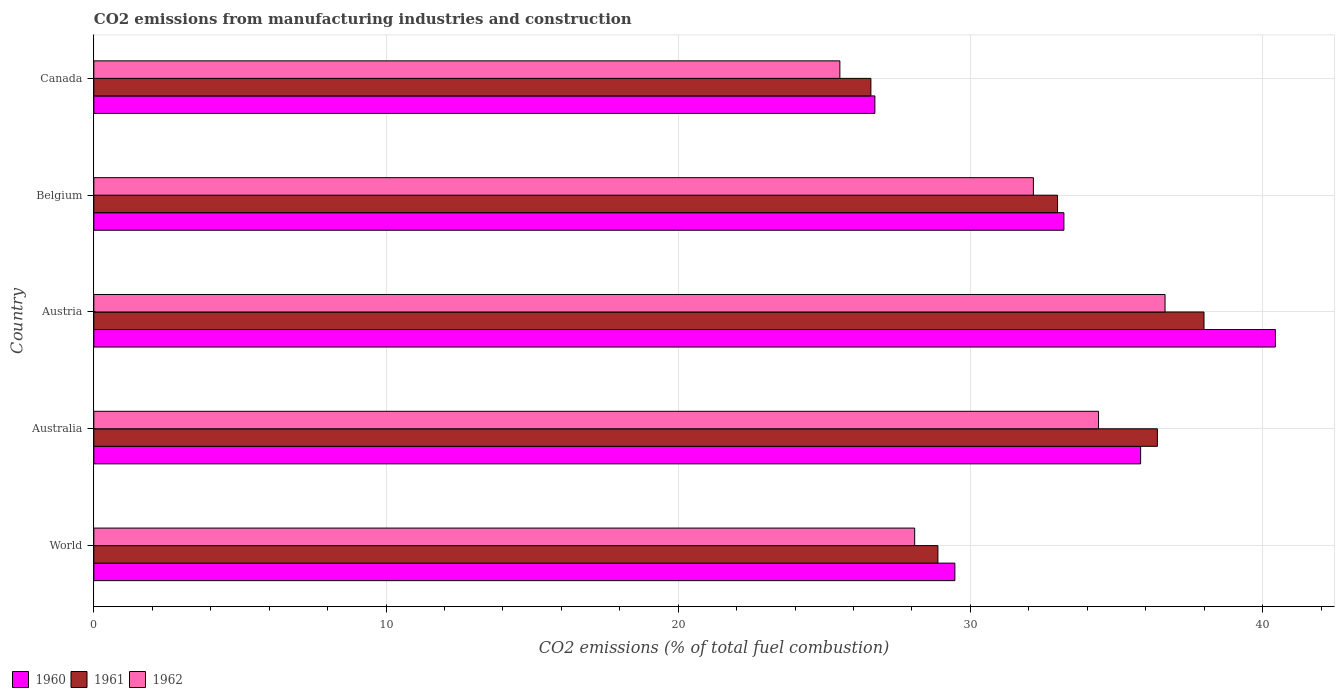How many bars are there on the 4th tick from the top?
Offer a very short reply. 3. How many bars are there on the 1st tick from the bottom?
Provide a short and direct response. 3. In how many cases, is the number of bars for a given country not equal to the number of legend labels?
Offer a terse response. 0. What is the amount of CO2 emitted in 1961 in Austria?
Offer a very short reply. 37.99. Across all countries, what is the maximum amount of CO2 emitted in 1961?
Your response must be concise. 37.99. Across all countries, what is the minimum amount of CO2 emitted in 1960?
Your response must be concise. 26.73. In which country was the amount of CO2 emitted in 1960 maximum?
Make the answer very short. Austria. What is the total amount of CO2 emitted in 1961 in the graph?
Your answer should be very brief. 162.86. What is the difference between the amount of CO2 emitted in 1960 in Australia and that in Canada?
Make the answer very short. 9.1. What is the difference between the amount of CO2 emitted in 1961 in Belgium and the amount of CO2 emitted in 1960 in Australia?
Your response must be concise. -2.84. What is the average amount of CO2 emitted in 1962 per country?
Ensure brevity in your answer.  31.37. What is the difference between the amount of CO2 emitted in 1960 and amount of CO2 emitted in 1962 in World?
Offer a very short reply. 1.38. What is the ratio of the amount of CO2 emitted in 1960 in Austria to that in Canada?
Make the answer very short. 1.51. Is the amount of CO2 emitted in 1960 in Australia less than that in Canada?
Ensure brevity in your answer.  No. What is the difference between the highest and the second highest amount of CO2 emitted in 1960?
Offer a very short reply. 4.61. What is the difference between the highest and the lowest amount of CO2 emitted in 1961?
Offer a terse response. 11.4. In how many countries, is the amount of CO2 emitted in 1960 greater than the average amount of CO2 emitted in 1960 taken over all countries?
Your response must be concise. 3. What does the 1st bar from the top in Austria represents?
Provide a succinct answer. 1962. What does the 2nd bar from the bottom in Canada represents?
Provide a succinct answer. 1961. Is it the case that in every country, the sum of the amount of CO2 emitted in 1961 and amount of CO2 emitted in 1960 is greater than the amount of CO2 emitted in 1962?
Keep it short and to the point. Yes. Are all the bars in the graph horizontal?
Provide a succinct answer. Yes. How many countries are there in the graph?
Your answer should be very brief. 5. Does the graph contain any zero values?
Offer a very short reply. No. Does the graph contain grids?
Ensure brevity in your answer.  Yes. How are the legend labels stacked?
Your response must be concise. Horizontal. What is the title of the graph?
Give a very brief answer. CO2 emissions from manufacturing industries and construction. What is the label or title of the X-axis?
Keep it short and to the point. CO2 emissions (% of total fuel combustion). What is the label or title of the Y-axis?
Offer a very short reply. Country. What is the CO2 emissions (% of total fuel combustion) of 1960 in World?
Ensure brevity in your answer.  29.47. What is the CO2 emissions (% of total fuel combustion) of 1961 in World?
Your response must be concise. 28.89. What is the CO2 emissions (% of total fuel combustion) in 1962 in World?
Ensure brevity in your answer.  28.09. What is the CO2 emissions (% of total fuel combustion) in 1960 in Australia?
Offer a terse response. 35.83. What is the CO2 emissions (% of total fuel combustion) of 1961 in Australia?
Make the answer very short. 36.4. What is the CO2 emissions (% of total fuel combustion) in 1962 in Australia?
Make the answer very short. 34.39. What is the CO2 emissions (% of total fuel combustion) in 1960 in Austria?
Give a very brief answer. 40.44. What is the CO2 emissions (% of total fuel combustion) of 1961 in Austria?
Provide a succinct answer. 37.99. What is the CO2 emissions (% of total fuel combustion) in 1962 in Austria?
Your answer should be compact. 36.66. What is the CO2 emissions (% of total fuel combustion) in 1960 in Belgium?
Your answer should be compact. 33.2. What is the CO2 emissions (% of total fuel combustion) of 1961 in Belgium?
Your answer should be very brief. 32.98. What is the CO2 emissions (% of total fuel combustion) in 1962 in Belgium?
Ensure brevity in your answer.  32.16. What is the CO2 emissions (% of total fuel combustion) of 1960 in Canada?
Provide a succinct answer. 26.73. What is the CO2 emissions (% of total fuel combustion) in 1961 in Canada?
Your answer should be compact. 26.59. What is the CO2 emissions (% of total fuel combustion) of 1962 in Canada?
Give a very brief answer. 25.53. Across all countries, what is the maximum CO2 emissions (% of total fuel combustion) in 1960?
Make the answer very short. 40.44. Across all countries, what is the maximum CO2 emissions (% of total fuel combustion) of 1961?
Offer a terse response. 37.99. Across all countries, what is the maximum CO2 emissions (% of total fuel combustion) in 1962?
Offer a very short reply. 36.66. Across all countries, what is the minimum CO2 emissions (% of total fuel combustion) in 1960?
Make the answer very short. 26.73. Across all countries, what is the minimum CO2 emissions (% of total fuel combustion) in 1961?
Offer a very short reply. 26.59. Across all countries, what is the minimum CO2 emissions (% of total fuel combustion) of 1962?
Ensure brevity in your answer.  25.53. What is the total CO2 emissions (% of total fuel combustion) of 1960 in the graph?
Provide a succinct answer. 165.66. What is the total CO2 emissions (% of total fuel combustion) of 1961 in the graph?
Offer a terse response. 162.86. What is the total CO2 emissions (% of total fuel combustion) in 1962 in the graph?
Offer a terse response. 156.83. What is the difference between the CO2 emissions (% of total fuel combustion) of 1960 in World and that in Australia?
Offer a terse response. -6.36. What is the difference between the CO2 emissions (% of total fuel combustion) in 1961 in World and that in Australia?
Offer a terse response. -7.51. What is the difference between the CO2 emissions (% of total fuel combustion) in 1962 in World and that in Australia?
Your response must be concise. -6.29. What is the difference between the CO2 emissions (% of total fuel combustion) in 1960 in World and that in Austria?
Your answer should be compact. -10.97. What is the difference between the CO2 emissions (% of total fuel combustion) of 1961 in World and that in Austria?
Your response must be concise. -9.11. What is the difference between the CO2 emissions (% of total fuel combustion) of 1962 in World and that in Austria?
Your answer should be very brief. -8.57. What is the difference between the CO2 emissions (% of total fuel combustion) in 1960 in World and that in Belgium?
Ensure brevity in your answer.  -3.73. What is the difference between the CO2 emissions (% of total fuel combustion) in 1961 in World and that in Belgium?
Provide a succinct answer. -4.09. What is the difference between the CO2 emissions (% of total fuel combustion) of 1962 in World and that in Belgium?
Offer a very short reply. -4.06. What is the difference between the CO2 emissions (% of total fuel combustion) of 1960 in World and that in Canada?
Make the answer very short. 2.74. What is the difference between the CO2 emissions (% of total fuel combustion) in 1961 in World and that in Canada?
Your answer should be very brief. 2.29. What is the difference between the CO2 emissions (% of total fuel combustion) of 1962 in World and that in Canada?
Make the answer very short. 2.56. What is the difference between the CO2 emissions (% of total fuel combustion) of 1960 in Australia and that in Austria?
Keep it short and to the point. -4.61. What is the difference between the CO2 emissions (% of total fuel combustion) of 1961 in Australia and that in Austria?
Provide a succinct answer. -1.6. What is the difference between the CO2 emissions (% of total fuel combustion) of 1962 in Australia and that in Austria?
Make the answer very short. -2.28. What is the difference between the CO2 emissions (% of total fuel combustion) in 1960 in Australia and that in Belgium?
Your response must be concise. 2.63. What is the difference between the CO2 emissions (% of total fuel combustion) in 1961 in Australia and that in Belgium?
Provide a short and direct response. 3.42. What is the difference between the CO2 emissions (% of total fuel combustion) in 1962 in Australia and that in Belgium?
Give a very brief answer. 2.23. What is the difference between the CO2 emissions (% of total fuel combustion) in 1960 in Australia and that in Canada?
Your response must be concise. 9.1. What is the difference between the CO2 emissions (% of total fuel combustion) of 1961 in Australia and that in Canada?
Give a very brief answer. 9.81. What is the difference between the CO2 emissions (% of total fuel combustion) in 1962 in Australia and that in Canada?
Offer a very short reply. 8.85. What is the difference between the CO2 emissions (% of total fuel combustion) in 1960 in Austria and that in Belgium?
Offer a very short reply. 7.24. What is the difference between the CO2 emissions (% of total fuel combustion) in 1961 in Austria and that in Belgium?
Give a very brief answer. 5.01. What is the difference between the CO2 emissions (% of total fuel combustion) of 1962 in Austria and that in Belgium?
Your response must be concise. 4.51. What is the difference between the CO2 emissions (% of total fuel combustion) of 1960 in Austria and that in Canada?
Your answer should be compact. 13.71. What is the difference between the CO2 emissions (% of total fuel combustion) in 1961 in Austria and that in Canada?
Offer a terse response. 11.4. What is the difference between the CO2 emissions (% of total fuel combustion) of 1962 in Austria and that in Canada?
Give a very brief answer. 11.13. What is the difference between the CO2 emissions (% of total fuel combustion) of 1960 in Belgium and that in Canada?
Make the answer very short. 6.47. What is the difference between the CO2 emissions (% of total fuel combustion) of 1961 in Belgium and that in Canada?
Provide a succinct answer. 6.39. What is the difference between the CO2 emissions (% of total fuel combustion) of 1962 in Belgium and that in Canada?
Ensure brevity in your answer.  6.62. What is the difference between the CO2 emissions (% of total fuel combustion) in 1960 in World and the CO2 emissions (% of total fuel combustion) in 1961 in Australia?
Provide a short and direct response. -6.93. What is the difference between the CO2 emissions (% of total fuel combustion) in 1960 in World and the CO2 emissions (% of total fuel combustion) in 1962 in Australia?
Your answer should be very brief. -4.92. What is the difference between the CO2 emissions (% of total fuel combustion) of 1961 in World and the CO2 emissions (% of total fuel combustion) of 1962 in Australia?
Offer a very short reply. -5.5. What is the difference between the CO2 emissions (% of total fuel combustion) of 1960 in World and the CO2 emissions (% of total fuel combustion) of 1961 in Austria?
Ensure brevity in your answer.  -8.53. What is the difference between the CO2 emissions (% of total fuel combustion) in 1960 in World and the CO2 emissions (% of total fuel combustion) in 1962 in Austria?
Your answer should be very brief. -7.19. What is the difference between the CO2 emissions (% of total fuel combustion) of 1961 in World and the CO2 emissions (% of total fuel combustion) of 1962 in Austria?
Give a very brief answer. -7.77. What is the difference between the CO2 emissions (% of total fuel combustion) in 1960 in World and the CO2 emissions (% of total fuel combustion) in 1961 in Belgium?
Your response must be concise. -3.51. What is the difference between the CO2 emissions (% of total fuel combustion) in 1960 in World and the CO2 emissions (% of total fuel combustion) in 1962 in Belgium?
Provide a succinct answer. -2.69. What is the difference between the CO2 emissions (% of total fuel combustion) in 1961 in World and the CO2 emissions (% of total fuel combustion) in 1962 in Belgium?
Give a very brief answer. -3.27. What is the difference between the CO2 emissions (% of total fuel combustion) of 1960 in World and the CO2 emissions (% of total fuel combustion) of 1961 in Canada?
Offer a very short reply. 2.87. What is the difference between the CO2 emissions (% of total fuel combustion) in 1960 in World and the CO2 emissions (% of total fuel combustion) in 1962 in Canada?
Your answer should be compact. 3.94. What is the difference between the CO2 emissions (% of total fuel combustion) in 1961 in World and the CO2 emissions (% of total fuel combustion) in 1962 in Canada?
Keep it short and to the point. 3.35. What is the difference between the CO2 emissions (% of total fuel combustion) in 1960 in Australia and the CO2 emissions (% of total fuel combustion) in 1961 in Austria?
Your answer should be compact. -2.17. What is the difference between the CO2 emissions (% of total fuel combustion) of 1960 in Australia and the CO2 emissions (% of total fuel combustion) of 1962 in Austria?
Offer a terse response. -0.84. What is the difference between the CO2 emissions (% of total fuel combustion) in 1961 in Australia and the CO2 emissions (% of total fuel combustion) in 1962 in Austria?
Make the answer very short. -0.26. What is the difference between the CO2 emissions (% of total fuel combustion) in 1960 in Australia and the CO2 emissions (% of total fuel combustion) in 1961 in Belgium?
Your answer should be very brief. 2.84. What is the difference between the CO2 emissions (% of total fuel combustion) in 1960 in Australia and the CO2 emissions (% of total fuel combustion) in 1962 in Belgium?
Make the answer very short. 3.67. What is the difference between the CO2 emissions (% of total fuel combustion) of 1961 in Australia and the CO2 emissions (% of total fuel combustion) of 1962 in Belgium?
Give a very brief answer. 4.24. What is the difference between the CO2 emissions (% of total fuel combustion) in 1960 in Australia and the CO2 emissions (% of total fuel combustion) in 1961 in Canada?
Offer a very short reply. 9.23. What is the difference between the CO2 emissions (% of total fuel combustion) of 1960 in Australia and the CO2 emissions (% of total fuel combustion) of 1962 in Canada?
Give a very brief answer. 10.29. What is the difference between the CO2 emissions (% of total fuel combustion) in 1961 in Australia and the CO2 emissions (% of total fuel combustion) in 1962 in Canada?
Your answer should be very brief. 10.87. What is the difference between the CO2 emissions (% of total fuel combustion) of 1960 in Austria and the CO2 emissions (% of total fuel combustion) of 1961 in Belgium?
Offer a very short reply. 7.46. What is the difference between the CO2 emissions (% of total fuel combustion) of 1960 in Austria and the CO2 emissions (% of total fuel combustion) of 1962 in Belgium?
Offer a terse response. 8.28. What is the difference between the CO2 emissions (% of total fuel combustion) in 1961 in Austria and the CO2 emissions (% of total fuel combustion) in 1962 in Belgium?
Your response must be concise. 5.84. What is the difference between the CO2 emissions (% of total fuel combustion) in 1960 in Austria and the CO2 emissions (% of total fuel combustion) in 1961 in Canada?
Offer a terse response. 13.84. What is the difference between the CO2 emissions (% of total fuel combustion) of 1960 in Austria and the CO2 emissions (% of total fuel combustion) of 1962 in Canada?
Provide a succinct answer. 14.91. What is the difference between the CO2 emissions (% of total fuel combustion) in 1961 in Austria and the CO2 emissions (% of total fuel combustion) in 1962 in Canada?
Offer a very short reply. 12.46. What is the difference between the CO2 emissions (% of total fuel combustion) of 1960 in Belgium and the CO2 emissions (% of total fuel combustion) of 1961 in Canada?
Offer a very short reply. 6.61. What is the difference between the CO2 emissions (% of total fuel combustion) of 1960 in Belgium and the CO2 emissions (% of total fuel combustion) of 1962 in Canada?
Provide a short and direct response. 7.67. What is the difference between the CO2 emissions (% of total fuel combustion) of 1961 in Belgium and the CO2 emissions (% of total fuel combustion) of 1962 in Canada?
Your answer should be compact. 7.45. What is the average CO2 emissions (% of total fuel combustion) in 1960 per country?
Your answer should be compact. 33.13. What is the average CO2 emissions (% of total fuel combustion) of 1961 per country?
Make the answer very short. 32.57. What is the average CO2 emissions (% of total fuel combustion) of 1962 per country?
Your answer should be very brief. 31.37. What is the difference between the CO2 emissions (% of total fuel combustion) in 1960 and CO2 emissions (% of total fuel combustion) in 1961 in World?
Give a very brief answer. 0.58. What is the difference between the CO2 emissions (% of total fuel combustion) in 1960 and CO2 emissions (% of total fuel combustion) in 1962 in World?
Give a very brief answer. 1.38. What is the difference between the CO2 emissions (% of total fuel combustion) in 1961 and CO2 emissions (% of total fuel combustion) in 1962 in World?
Provide a succinct answer. 0.79. What is the difference between the CO2 emissions (% of total fuel combustion) in 1960 and CO2 emissions (% of total fuel combustion) in 1961 in Australia?
Keep it short and to the point. -0.57. What is the difference between the CO2 emissions (% of total fuel combustion) in 1960 and CO2 emissions (% of total fuel combustion) in 1962 in Australia?
Make the answer very short. 1.44. What is the difference between the CO2 emissions (% of total fuel combustion) in 1961 and CO2 emissions (% of total fuel combustion) in 1962 in Australia?
Provide a short and direct response. 2.01. What is the difference between the CO2 emissions (% of total fuel combustion) of 1960 and CO2 emissions (% of total fuel combustion) of 1961 in Austria?
Provide a succinct answer. 2.44. What is the difference between the CO2 emissions (% of total fuel combustion) in 1960 and CO2 emissions (% of total fuel combustion) in 1962 in Austria?
Offer a terse response. 3.78. What is the difference between the CO2 emissions (% of total fuel combustion) in 1961 and CO2 emissions (% of total fuel combustion) in 1962 in Austria?
Provide a short and direct response. 1.33. What is the difference between the CO2 emissions (% of total fuel combustion) of 1960 and CO2 emissions (% of total fuel combustion) of 1961 in Belgium?
Give a very brief answer. 0.22. What is the difference between the CO2 emissions (% of total fuel combustion) of 1960 and CO2 emissions (% of total fuel combustion) of 1962 in Belgium?
Give a very brief answer. 1.04. What is the difference between the CO2 emissions (% of total fuel combustion) in 1961 and CO2 emissions (% of total fuel combustion) in 1962 in Belgium?
Your answer should be compact. 0.83. What is the difference between the CO2 emissions (% of total fuel combustion) in 1960 and CO2 emissions (% of total fuel combustion) in 1961 in Canada?
Your response must be concise. 0.14. What is the difference between the CO2 emissions (% of total fuel combustion) in 1960 and CO2 emissions (% of total fuel combustion) in 1962 in Canada?
Your answer should be compact. 1.2. What is the difference between the CO2 emissions (% of total fuel combustion) of 1961 and CO2 emissions (% of total fuel combustion) of 1962 in Canada?
Give a very brief answer. 1.06. What is the ratio of the CO2 emissions (% of total fuel combustion) in 1960 in World to that in Australia?
Provide a short and direct response. 0.82. What is the ratio of the CO2 emissions (% of total fuel combustion) in 1961 in World to that in Australia?
Make the answer very short. 0.79. What is the ratio of the CO2 emissions (% of total fuel combustion) of 1962 in World to that in Australia?
Offer a terse response. 0.82. What is the ratio of the CO2 emissions (% of total fuel combustion) in 1960 in World to that in Austria?
Offer a very short reply. 0.73. What is the ratio of the CO2 emissions (% of total fuel combustion) of 1961 in World to that in Austria?
Offer a terse response. 0.76. What is the ratio of the CO2 emissions (% of total fuel combustion) of 1962 in World to that in Austria?
Keep it short and to the point. 0.77. What is the ratio of the CO2 emissions (% of total fuel combustion) of 1960 in World to that in Belgium?
Your response must be concise. 0.89. What is the ratio of the CO2 emissions (% of total fuel combustion) of 1961 in World to that in Belgium?
Offer a terse response. 0.88. What is the ratio of the CO2 emissions (% of total fuel combustion) in 1962 in World to that in Belgium?
Your answer should be very brief. 0.87. What is the ratio of the CO2 emissions (% of total fuel combustion) of 1960 in World to that in Canada?
Your answer should be very brief. 1.1. What is the ratio of the CO2 emissions (% of total fuel combustion) in 1961 in World to that in Canada?
Your answer should be compact. 1.09. What is the ratio of the CO2 emissions (% of total fuel combustion) of 1962 in World to that in Canada?
Your answer should be very brief. 1.1. What is the ratio of the CO2 emissions (% of total fuel combustion) of 1960 in Australia to that in Austria?
Give a very brief answer. 0.89. What is the ratio of the CO2 emissions (% of total fuel combustion) of 1961 in Australia to that in Austria?
Offer a terse response. 0.96. What is the ratio of the CO2 emissions (% of total fuel combustion) of 1962 in Australia to that in Austria?
Make the answer very short. 0.94. What is the ratio of the CO2 emissions (% of total fuel combustion) of 1960 in Australia to that in Belgium?
Your answer should be very brief. 1.08. What is the ratio of the CO2 emissions (% of total fuel combustion) of 1961 in Australia to that in Belgium?
Make the answer very short. 1.1. What is the ratio of the CO2 emissions (% of total fuel combustion) in 1962 in Australia to that in Belgium?
Offer a very short reply. 1.07. What is the ratio of the CO2 emissions (% of total fuel combustion) in 1960 in Australia to that in Canada?
Your response must be concise. 1.34. What is the ratio of the CO2 emissions (% of total fuel combustion) of 1961 in Australia to that in Canada?
Provide a short and direct response. 1.37. What is the ratio of the CO2 emissions (% of total fuel combustion) in 1962 in Australia to that in Canada?
Your response must be concise. 1.35. What is the ratio of the CO2 emissions (% of total fuel combustion) in 1960 in Austria to that in Belgium?
Keep it short and to the point. 1.22. What is the ratio of the CO2 emissions (% of total fuel combustion) in 1961 in Austria to that in Belgium?
Keep it short and to the point. 1.15. What is the ratio of the CO2 emissions (% of total fuel combustion) of 1962 in Austria to that in Belgium?
Offer a very short reply. 1.14. What is the ratio of the CO2 emissions (% of total fuel combustion) in 1960 in Austria to that in Canada?
Your response must be concise. 1.51. What is the ratio of the CO2 emissions (% of total fuel combustion) in 1961 in Austria to that in Canada?
Your response must be concise. 1.43. What is the ratio of the CO2 emissions (% of total fuel combustion) in 1962 in Austria to that in Canada?
Keep it short and to the point. 1.44. What is the ratio of the CO2 emissions (% of total fuel combustion) in 1960 in Belgium to that in Canada?
Your response must be concise. 1.24. What is the ratio of the CO2 emissions (% of total fuel combustion) of 1961 in Belgium to that in Canada?
Your answer should be compact. 1.24. What is the ratio of the CO2 emissions (% of total fuel combustion) in 1962 in Belgium to that in Canada?
Ensure brevity in your answer.  1.26. What is the difference between the highest and the second highest CO2 emissions (% of total fuel combustion) of 1960?
Keep it short and to the point. 4.61. What is the difference between the highest and the second highest CO2 emissions (% of total fuel combustion) of 1961?
Offer a very short reply. 1.6. What is the difference between the highest and the second highest CO2 emissions (% of total fuel combustion) in 1962?
Give a very brief answer. 2.28. What is the difference between the highest and the lowest CO2 emissions (% of total fuel combustion) in 1960?
Offer a very short reply. 13.71. What is the difference between the highest and the lowest CO2 emissions (% of total fuel combustion) of 1961?
Offer a terse response. 11.4. What is the difference between the highest and the lowest CO2 emissions (% of total fuel combustion) in 1962?
Your response must be concise. 11.13. 